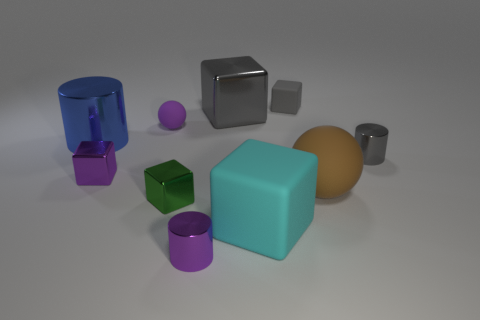What size is the cylinder that is the same color as the small matte cube?
Offer a terse response. Small. Is there any other thing that has the same color as the large rubber sphere?
Provide a short and direct response. No. There is a big matte thing that is on the right side of the gray cube right of the large block behind the brown rubber sphere; what is its color?
Your answer should be compact. Brown. What is the size of the sphere that is behind the metallic object to the right of the big gray metal thing?
Your response must be concise. Small. The object that is in front of the brown matte thing and behind the large matte cube is made of what material?
Give a very brief answer. Metal. There is a purple cylinder; is its size the same as the rubber thing that is to the left of the large cyan rubber thing?
Keep it short and to the point. Yes. Are there any small red metallic balls?
Provide a succinct answer. No. What material is the tiny purple object that is the same shape as the gray rubber object?
Your answer should be compact. Metal. What size is the rubber ball right of the matte thing on the left side of the tiny purple thing that is in front of the big cyan matte cube?
Your response must be concise. Large. There is a gray matte thing; are there any green objects right of it?
Give a very brief answer. No. 